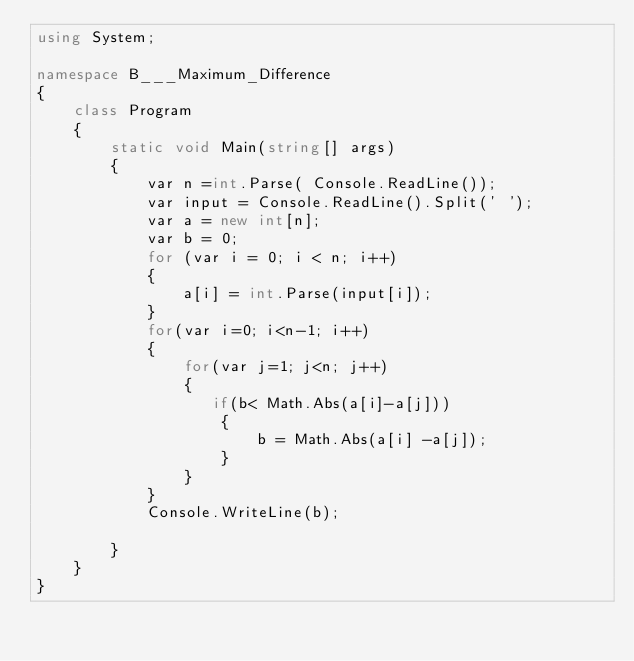<code> <loc_0><loc_0><loc_500><loc_500><_C#_>using System;

namespace B___Maximum_Difference
{
    class Program
    {
        static void Main(string[] args)
        {
            var n =int.Parse( Console.ReadLine());
            var input = Console.ReadLine().Split(' ');
            var a = new int[n];
            var b = 0;
            for (var i = 0; i < n; i++)
            {
                a[i] = int.Parse(input[i]);
            }
            for(var i=0; i<n-1; i++)
            {
                for(var j=1; j<n; j++)
                {
                   if(b< Math.Abs(a[i]-a[j]))
                    {
                        b = Math.Abs(a[i] -a[j]);
                    }
                }
            }
            Console.WriteLine(b);
           
        }
    }
}</code> 